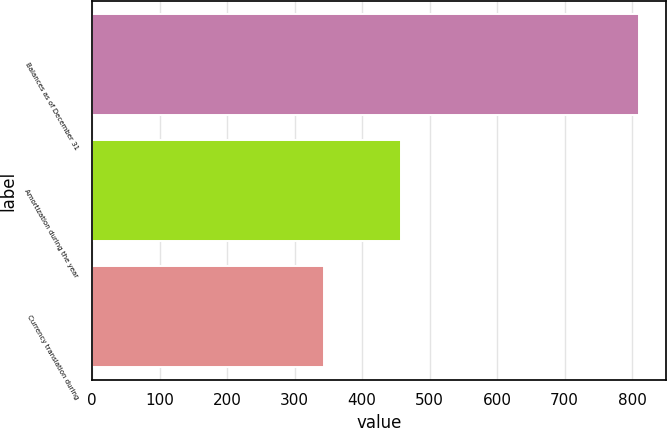<chart> <loc_0><loc_0><loc_500><loc_500><bar_chart><fcel>Balances as of December 31<fcel>Amortization during the year<fcel>Currency translation during<nl><fcel>810<fcel>458<fcel>344<nl></chart> 